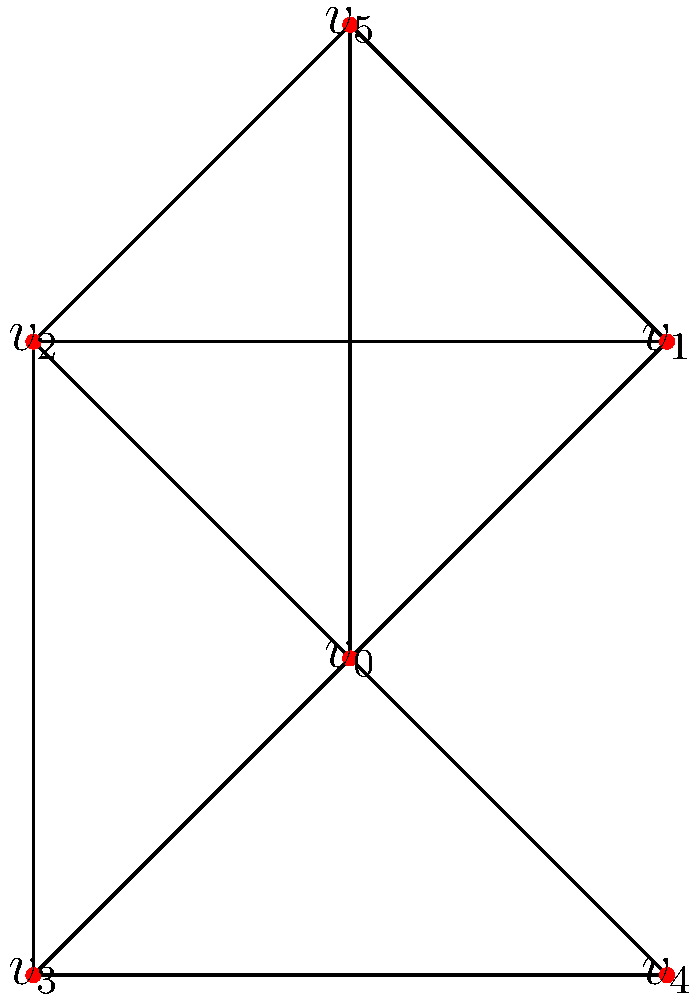In the context of a social network affected by persuasive technology, the graph represents users and their connections. Calculate the degree centrality and betweenness centrality for vertex $v_0$. Which centrality measure suggests that $v_0$ has a more influential position in the network? To answer this question, we need to calculate both the degree centrality and betweenness centrality for vertex $v_0$:

1. Degree Centrality:
   - Degree centrality is the number of direct connections a node has.
   - For $v_0$, we can count 5 direct connections (to $v_1$, $v_2$, $v_3$, $v_4$, and $v_5$).
   - Normalized degree centrality: $C_D(v_0) = \frac{5}{5} = 1$ (since there are 5 possible connections in a network with 6 nodes)

2. Betweenness Centrality:
   - Betweenness centrality measures the extent to which a node lies on the shortest paths between other nodes.
   - We need to calculate the fraction of shortest paths that pass through $v_0$.
   - There are 15 pairs of nodes (excluding $v_0$).
   - $v_0$ lies on the shortest path for 8 of these pairs: ($v_1$-$v_3$), ($v_1$-$v_4$), ($v_2$-$v_4$), ($v_3$-$v_5$), ($v_4$-$v_5$), ($v_1$-$v_2$), ($v_2$-$v_3$), ($v_3$-$v_4$)
   - Betweenness centrality: $C_B(v_0) = \frac{8}{15} \approx 0.533$

3. Comparison:
   - Degree centrality: 1 (maximum possible value)
   - Betweenness centrality: 0.533

The degree centrality of 1 (the maximum possible value) suggests that $v_0$ has direct connections to all other nodes in the network. This indicates a highly influential position in terms of direct reach and immediate impact.

The betweenness centrality of 0.533, while significant, is not as high relative to its maximum possible value. This suggests that while $v_0$ is important for information flow, it doesn't completely dominate all shortest paths in the network.

In the context of persuasive technology, a high degree centrality implies that $v_0$ can directly influence or be influenced by all other users in the network. This direct access to all other nodes makes it a more influential position for spreading or controlling the effects of persuasive technology.
Answer: Degree centrality (1.0) suggests $v_0$ has a more influential position. 